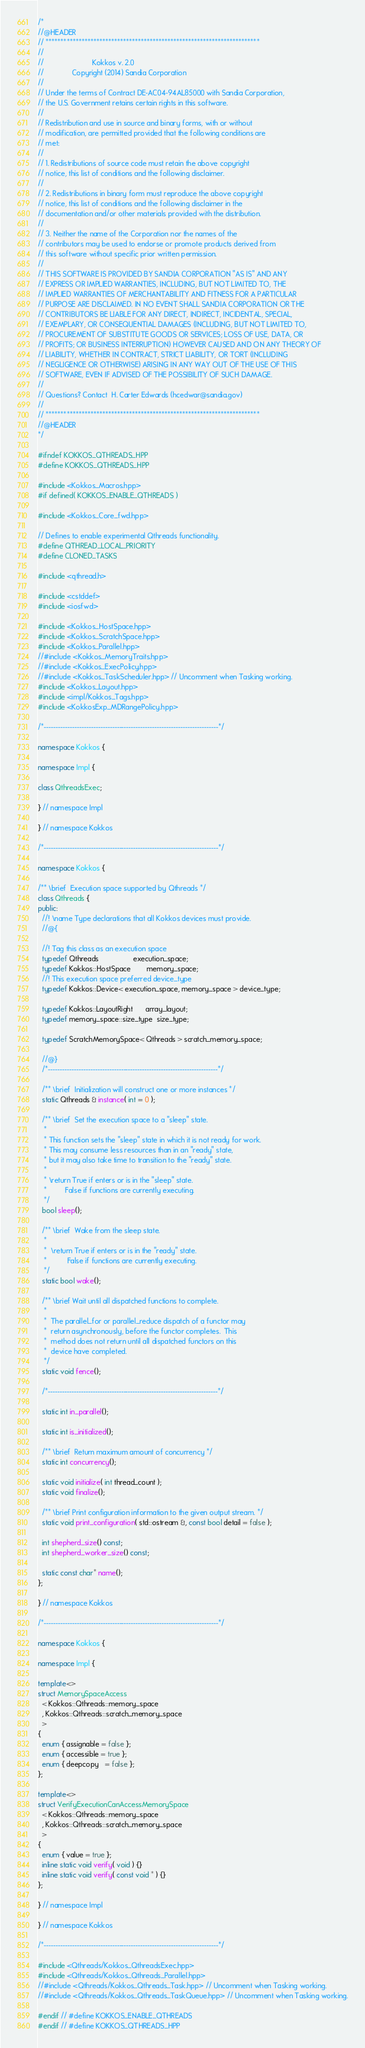<code> <loc_0><loc_0><loc_500><loc_500><_C++_>/*
//@HEADER
// ************************************************************************
//
//                        Kokkos v. 2.0
//              Copyright (2014) Sandia Corporation
//
// Under the terms of Contract DE-AC04-94AL85000 with Sandia Corporation,
// the U.S. Government retains certain rights in this software.
//
// Redistribution and use in source and binary forms, with or without
// modification, are permitted provided that the following conditions are
// met:
//
// 1. Redistributions of source code must retain the above copyright
// notice, this list of conditions and the following disclaimer.
//
// 2. Redistributions in binary form must reproduce the above copyright
// notice, this list of conditions and the following disclaimer in the
// documentation and/or other materials provided with the distribution.
//
// 3. Neither the name of the Corporation nor the names of the
// contributors may be used to endorse or promote products derived from
// this software without specific prior written permission.
//
// THIS SOFTWARE IS PROVIDED BY SANDIA CORPORATION "AS IS" AND ANY
// EXPRESS OR IMPLIED WARRANTIES, INCLUDING, BUT NOT LIMITED TO, THE
// IMPLIED WARRANTIES OF MERCHANTABILITY AND FITNESS FOR A PARTICULAR
// PURPOSE ARE DISCLAIMED. IN NO EVENT SHALL SANDIA CORPORATION OR THE
// CONTRIBUTORS BE LIABLE FOR ANY DIRECT, INDIRECT, INCIDENTAL, SPECIAL,
// EXEMPLARY, OR CONSEQUENTIAL DAMAGES (INCLUDING, BUT NOT LIMITED TO,
// PROCUREMENT OF SUBSTITUTE GOODS OR SERVICES; LOSS OF USE, DATA, OR
// PROFITS; OR BUSINESS INTERRUPTION) HOWEVER CAUSED AND ON ANY THEORY OF
// LIABILITY, WHETHER IN CONTRACT, STRICT LIABILITY, OR TORT (INCLUDING
// NEGLIGENCE OR OTHERWISE) ARISING IN ANY WAY OUT OF THE USE OF THIS
// SOFTWARE, EVEN IF ADVISED OF THE POSSIBILITY OF SUCH DAMAGE.
//
// Questions? Contact  H. Carter Edwards (hcedwar@sandia.gov)
//
// ************************************************************************
//@HEADER
*/

#ifndef KOKKOS_QTHREADS_HPP
#define KOKKOS_QTHREADS_HPP

#include <Kokkos_Macros.hpp>
#if defined( KOKKOS_ENABLE_QTHREADS )

#include <Kokkos_Core_fwd.hpp>

// Defines to enable experimental Qthreads functionality.
#define QTHREAD_LOCAL_PRIORITY
#define CLONED_TASKS

#include <qthread.h>

#include <cstddef>
#include <iosfwd>

#include <Kokkos_HostSpace.hpp>
#include <Kokkos_ScratchSpace.hpp>
#include <Kokkos_Parallel.hpp>
//#include <Kokkos_MemoryTraits.hpp>
//#include <Kokkos_ExecPolicy.hpp>
//#include <Kokkos_TaskScheduler.hpp> // Uncomment when Tasking working.
#include <Kokkos_Layout.hpp>
#include <impl/Kokkos_Tags.hpp>
#include <KokkosExp_MDRangePolicy.hpp>

/*--------------------------------------------------------------------------*/

namespace Kokkos {

namespace Impl {

class QthreadsExec;

} // namespace Impl

} // namespace Kokkos

/*--------------------------------------------------------------------------*/

namespace Kokkos {

/** \brief  Execution space supported by Qthreads */
class Qthreads {
public:
  //! \name Type declarations that all Kokkos devices must provide.
  //@{

  //! Tag this class as an execution space
  typedef Qthreads                 execution_space;
  typedef Kokkos::HostSpace        memory_space;
  //! This execution space preferred device_type
  typedef Kokkos::Device< execution_space, memory_space > device_type;

  typedef Kokkos::LayoutRight      array_layout;
  typedef memory_space::size_type  size_type;

  typedef ScratchMemorySpace< Qthreads > scratch_memory_space;

  //@}
  /*------------------------------------------------------------------------*/

  /** \brief  Initialization will construct one or more instances */
  static Qthreads & instance( int = 0 );

  /** \brief  Set the execution space to a "sleep" state.
   *
   * This function sets the "sleep" state in which it is not ready for work.
   * This may consume less resources than in an "ready" state,
   * but it may also take time to transition to the "ready" state.
   *
   * \return True if enters or is in the "sleep" state.
   *         False if functions are currently executing.
   */
  bool sleep();

  /** \brief  Wake from the sleep state.
   *
   *  \return True if enters or is in the "ready" state.
   *          False if functions are currently executing.
   */
  static bool wake();

  /** \brief Wait until all dispatched functions to complete.
   *
   *  The parallel_for or parallel_reduce dispatch of a functor may
   *  return asynchronously, before the functor completes.  This
   *  method does not return until all dispatched functors on this
   *  device have completed.
   */
  static void fence();

  /*------------------------------------------------------------------------*/

  static int in_parallel();

  static int is_initialized();

  /** \brief  Return maximum amount of concurrency */
  static int concurrency();

  static void initialize( int thread_count );
  static void finalize();

  /** \brief Print configuration information to the given output stream. */
  static void print_configuration( std::ostream &, const bool detail = false );

  int shepherd_size() const;
  int shepherd_worker_size() const;

  static const char* name();
};

} // namespace Kokkos

/*--------------------------------------------------------------------------*/

namespace Kokkos {

namespace Impl {

template<>
struct MemorySpaceAccess
  < Kokkos::Qthreads::memory_space
  , Kokkos::Qthreads::scratch_memory_space
  >
{
  enum { assignable = false };
  enum { accessible = true };
  enum { deepcopy   = false };
};

template<>
struct VerifyExecutionCanAccessMemorySpace
  < Kokkos::Qthreads::memory_space
  , Kokkos::Qthreads::scratch_memory_space
  >
{
  enum { value = true };
  inline static void verify( void ) {}
  inline static void verify( const void * ) {}
};

} // namespace Impl

} // namespace Kokkos

/*--------------------------------------------------------------------------*/

#include <Qthreads/Kokkos_QthreadsExec.hpp>
#include <Qthreads/Kokkos_Qthreads_Parallel.hpp>
//#include <Qthreads/Kokkos_Qthreads_Task.hpp> // Uncomment when Tasking working.
//#include <Qthreads/Kokkos_Qthreads_TaskQueue.hpp> // Uncomment when Tasking working.

#endif // #define KOKKOS_ENABLE_QTHREADS
#endif // #define KOKKOS_QTHREADS_HPP

</code> 